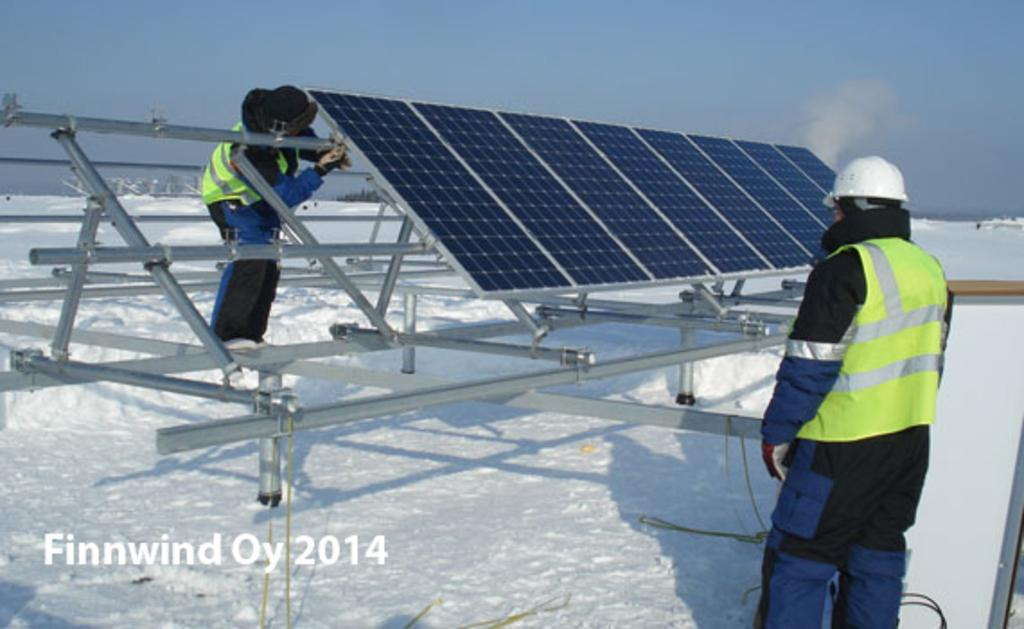What is the main subject in the center of the image? There are persons in the center of the image. What can be seen on the snow in the image? Solar panels are present on the snow. What is visible in the background of the image? The background of the image includes the sky. How many ants are crawling on the wall in the image? There are no ants or walls present in the image. What stage of development is the solar panel project in the image? There is no indication of a solar panel project or its development stage in the image. 